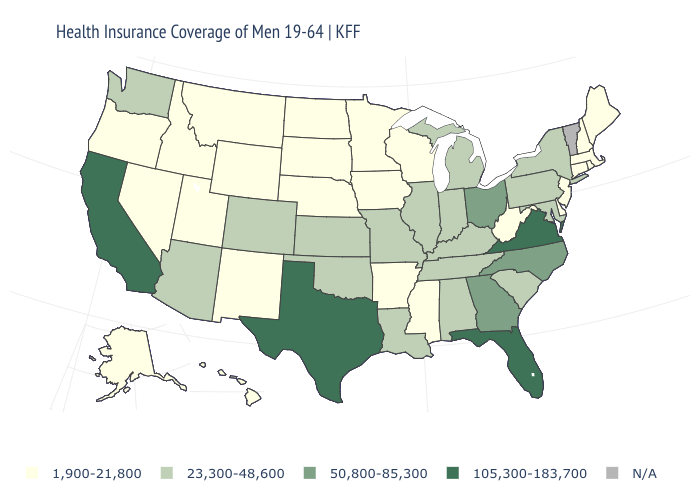What is the value of Alaska?
Keep it brief. 1,900-21,800. What is the value of Hawaii?
Answer briefly. 1,900-21,800. What is the highest value in states that border Washington?
Quick response, please. 1,900-21,800. Which states have the lowest value in the USA?
Give a very brief answer. Alaska, Arkansas, Connecticut, Delaware, Hawaii, Idaho, Iowa, Maine, Massachusetts, Minnesota, Mississippi, Montana, Nebraska, Nevada, New Hampshire, New Jersey, New Mexico, North Dakota, Oregon, Rhode Island, South Dakota, Utah, West Virginia, Wisconsin, Wyoming. Which states have the lowest value in the USA?
Concise answer only. Alaska, Arkansas, Connecticut, Delaware, Hawaii, Idaho, Iowa, Maine, Massachusetts, Minnesota, Mississippi, Montana, Nebraska, Nevada, New Hampshire, New Jersey, New Mexico, North Dakota, Oregon, Rhode Island, South Dakota, Utah, West Virginia, Wisconsin, Wyoming. What is the value of Florida?
Write a very short answer. 105,300-183,700. Does Massachusetts have the lowest value in the USA?
Concise answer only. Yes. What is the value of Mississippi?
Be succinct. 1,900-21,800. Name the states that have a value in the range 23,300-48,600?
Quick response, please. Alabama, Arizona, Colorado, Illinois, Indiana, Kansas, Kentucky, Louisiana, Maryland, Michigan, Missouri, New York, Oklahoma, Pennsylvania, South Carolina, Tennessee, Washington. Does Delaware have the highest value in the USA?
Give a very brief answer. No. Name the states that have a value in the range 50,800-85,300?
Answer briefly. Georgia, North Carolina, Ohio. Name the states that have a value in the range 105,300-183,700?
Give a very brief answer. California, Florida, Texas, Virginia. Among the states that border Massachusetts , does New York have the highest value?
Be succinct. Yes. Which states have the highest value in the USA?
Be succinct. California, Florida, Texas, Virginia. What is the value of Massachusetts?
Write a very short answer. 1,900-21,800. 